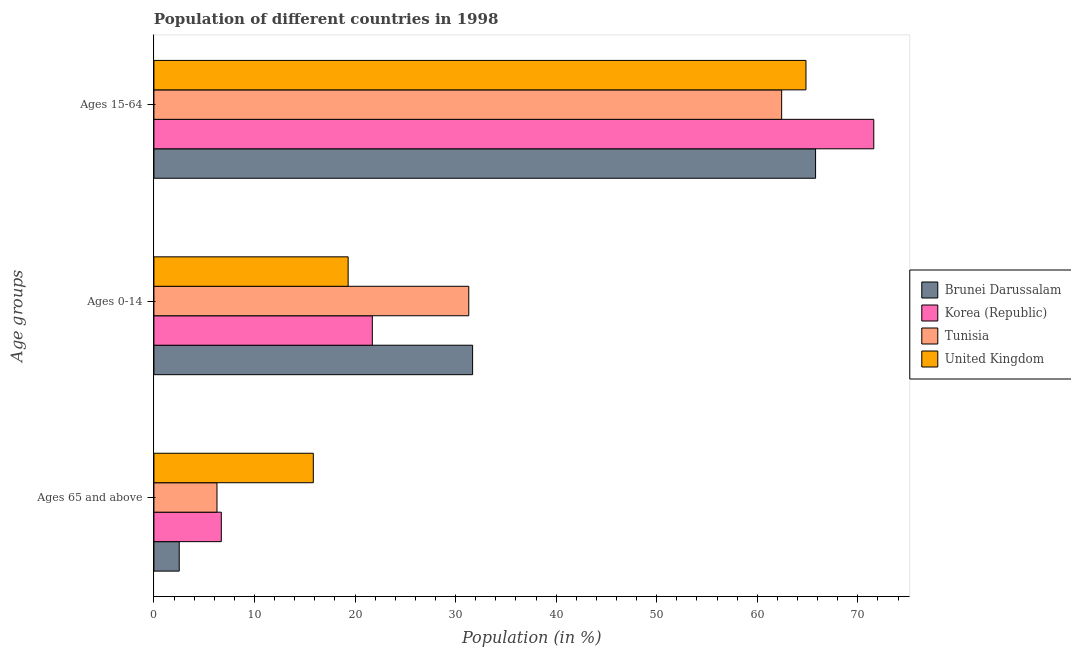Are the number of bars per tick equal to the number of legend labels?
Keep it short and to the point. Yes. Are the number of bars on each tick of the Y-axis equal?
Your response must be concise. Yes. What is the label of the 2nd group of bars from the top?
Give a very brief answer. Ages 0-14. What is the percentage of population within the age-group of 65 and above in United Kingdom?
Provide a short and direct response. 15.85. Across all countries, what is the maximum percentage of population within the age-group 15-64?
Provide a short and direct response. 71.58. Across all countries, what is the minimum percentage of population within the age-group 15-64?
Make the answer very short. 62.42. In which country was the percentage of population within the age-group 15-64 minimum?
Provide a succinct answer. Tunisia. What is the total percentage of population within the age-group of 65 and above in the graph?
Provide a short and direct response. 31.34. What is the difference between the percentage of population within the age-group of 65 and above in Tunisia and that in Korea (Republic)?
Keep it short and to the point. -0.43. What is the difference between the percentage of population within the age-group of 65 and above in Tunisia and the percentage of population within the age-group 15-64 in United Kingdom?
Ensure brevity in your answer.  -58.57. What is the average percentage of population within the age-group 0-14 per country?
Make the answer very short. 26.01. What is the difference between the percentage of population within the age-group of 65 and above and percentage of population within the age-group 15-64 in Brunei Darussalam?
Provide a short and direct response. -63.28. In how many countries, is the percentage of population within the age-group 0-14 greater than 70 %?
Offer a terse response. 0. What is the ratio of the percentage of population within the age-group 0-14 in United Kingdom to that in Brunei Darussalam?
Offer a very short reply. 0.61. Is the percentage of population within the age-group 15-64 in Korea (Republic) less than that in Tunisia?
Keep it short and to the point. No. Is the difference between the percentage of population within the age-group 15-64 in United Kingdom and Brunei Darussalam greater than the difference between the percentage of population within the age-group 0-14 in United Kingdom and Brunei Darussalam?
Your answer should be compact. Yes. What is the difference between the highest and the second highest percentage of population within the age-group of 65 and above?
Ensure brevity in your answer.  9.15. What is the difference between the highest and the lowest percentage of population within the age-group 0-14?
Ensure brevity in your answer.  12.38. In how many countries, is the percentage of population within the age-group of 65 and above greater than the average percentage of population within the age-group of 65 and above taken over all countries?
Provide a short and direct response. 1. What does the 4th bar from the bottom in Ages 15-64 represents?
Offer a terse response. United Kingdom. How many bars are there?
Offer a terse response. 12. How many countries are there in the graph?
Your answer should be very brief. 4. What is the difference between two consecutive major ticks on the X-axis?
Provide a succinct answer. 10. Does the graph contain grids?
Offer a very short reply. No. Where does the legend appear in the graph?
Your answer should be very brief. Center right. How are the legend labels stacked?
Ensure brevity in your answer.  Vertical. What is the title of the graph?
Provide a short and direct response. Population of different countries in 1998. Does "Benin" appear as one of the legend labels in the graph?
Offer a very short reply. No. What is the label or title of the X-axis?
Your answer should be compact. Population (in %). What is the label or title of the Y-axis?
Make the answer very short. Age groups. What is the Population (in %) in Brunei Darussalam in Ages 65 and above?
Give a very brief answer. 2.52. What is the Population (in %) in Korea (Republic) in Ages 65 and above?
Give a very brief answer. 6.7. What is the Population (in %) of Tunisia in Ages 65 and above?
Your response must be concise. 6.27. What is the Population (in %) of United Kingdom in Ages 65 and above?
Make the answer very short. 15.85. What is the Population (in %) of Brunei Darussalam in Ages 0-14?
Keep it short and to the point. 31.69. What is the Population (in %) in Korea (Republic) in Ages 0-14?
Provide a short and direct response. 21.72. What is the Population (in %) of Tunisia in Ages 0-14?
Give a very brief answer. 31.31. What is the Population (in %) of United Kingdom in Ages 0-14?
Provide a short and direct response. 19.31. What is the Population (in %) in Brunei Darussalam in Ages 15-64?
Keep it short and to the point. 65.79. What is the Population (in %) in Korea (Republic) in Ages 15-64?
Provide a succinct answer. 71.58. What is the Population (in %) of Tunisia in Ages 15-64?
Keep it short and to the point. 62.42. What is the Population (in %) in United Kingdom in Ages 15-64?
Provide a short and direct response. 64.84. Across all Age groups, what is the maximum Population (in %) in Brunei Darussalam?
Offer a very short reply. 65.79. Across all Age groups, what is the maximum Population (in %) of Korea (Republic)?
Offer a very short reply. 71.58. Across all Age groups, what is the maximum Population (in %) in Tunisia?
Offer a terse response. 62.42. Across all Age groups, what is the maximum Population (in %) in United Kingdom?
Your answer should be very brief. 64.84. Across all Age groups, what is the minimum Population (in %) of Brunei Darussalam?
Keep it short and to the point. 2.52. Across all Age groups, what is the minimum Population (in %) of Korea (Republic)?
Provide a short and direct response. 6.7. Across all Age groups, what is the minimum Population (in %) of Tunisia?
Keep it short and to the point. 6.27. Across all Age groups, what is the minimum Population (in %) of United Kingdom?
Provide a succinct answer. 15.85. What is the total Population (in %) in Brunei Darussalam in the graph?
Your answer should be very brief. 100. What is the total Population (in %) of Tunisia in the graph?
Provide a short and direct response. 100. What is the total Population (in %) of United Kingdom in the graph?
Make the answer very short. 100. What is the difference between the Population (in %) in Brunei Darussalam in Ages 65 and above and that in Ages 0-14?
Your response must be concise. -29.17. What is the difference between the Population (in %) in Korea (Republic) in Ages 65 and above and that in Ages 0-14?
Give a very brief answer. -15.02. What is the difference between the Population (in %) of Tunisia in Ages 65 and above and that in Ages 0-14?
Keep it short and to the point. -25.04. What is the difference between the Population (in %) of United Kingdom in Ages 65 and above and that in Ages 0-14?
Your answer should be compact. -3.46. What is the difference between the Population (in %) in Brunei Darussalam in Ages 65 and above and that in Ages 15-64?
Ensure brevity in your answer.  -63.28. What is the difference between the Population (in %) in Korea (Republic) in Ages 65 and above and that in Ages 15-64?
Provide a short and direct response. -64.88. What is the difference between the Population (in %) in Tunisia in Ages 65 and above and that in Ages 15-64?
Offer a terse response. -56.15. What is the difference between the Population (in %) of United Kingdom in Ages 65 and above and that in Ages 15-64?
Your answer should be compact. -48.99. What is the difference between the Population (in %) of Brunei Darussalam in Ages 0-14 and that in Ages 15-64?
Your answer should be compact. -34.11. What is the difference between the Population (in %) in Korea (Republic) in Ages 0-14 and that in Ages 15-64?
Offer a very short reply. -49.86. What is the difference between the Population (in %) in Tunisia in Ages 0-14 and that in Ages 15-64?
Offer a very short reply. -31.11. What is the difference between the Population (in %) of United Kingdom in Ages 0-14 and that in Ages 15-64?
Offer a very short reply. -45.53. What is the difference between the Population (in %) of Brunei Darussalam in Ages 65 and above and the Population (in %) of Korea (Republic) in Ages 0-14?
Keep it short and to the point. -19.2. What is the difference between the Population (in %) in Brunei Darussalam in Ages 65 and above and the Population (in %) in Tunisia in Ages 0-14?
Offer a very short reply. -28.79. What is the difference between the Population (in %) in Brunei Darussalam in Ages 65 and above and the Population (in %) in United Kingdom in Ages 0-14?
Give a very brief answer. -16.8. What is the difference between the Population (in %) in Korea (Republic) in Ages 65 and above and the Population (in %) in Tunisia in Ages 0-14?
Ensure brevity in your answer.  -24.61. What is the difference between the Population (in %) in Korea (Republic) in Ages 65 and above and the Population (in %) in United Kingdom in Ages 0-14?
Make the answer very short. -12.61. What is the difference between the Population (in %) in Tunisia in Ages 65 and above and the Population (in %) in United Kingdom in Ages 0-14?
Your answer should be compact. -13.04. What is the difference between the Population (in %) of Brunei Darussalam in Ages 65 and above and the Population (in %) of Korea (Republic) in Ages 15-64?
Your answer should be compact. -69.06. What is the difference between the Population (in %) of Brunei Darussalam in Ages 65 and above and the Population (in %) of Tunisia in Ages 15-64?
Give a very brief answer. -59.9. What is the difference between the Population (in %) in Brunei Darussalam in Ages 65 and above and the Population (in %) in United Kingdom in Ages 15-64?
Your answer should be compact. -62.32. What is the difference between the Population (in %) of Korea (Republic) in Ages 65 and above and the Population (in %) of Tunisia in Ages 15-64?
Ensure brevity in your answer.  -55.72. What is the difference between the Population (in %) of Korea (Republic) in Ages 65 and above and the Population (in %) of United Kingdom in Ages 15-64?
Provide a succinct answer. -58.14. What is the difference between the Population (in %) in Tunisia in Ages 65 and above and the Population (in %) in United Kingdom in Ages 15-64?
Give a very brief answer. -58.57. What is the difference between the Population (in %) of Brunei Darussalam in Ages 0-14 and the Population (in %) of Korea (Republic) in Ages 15-64?
Make the answer very short. -39.89. What is the difference between the Population (in %) of Brunei Darussalam in Ages 0-14 and the Population (in %) of Tunisia in Ages 15-64?
Provide a succinct answer. -30.73. What is the difference between the Population (in %) of Brunei Darussalam in Ages 0-14 and the Population (in %) of United Kingdom in Ages 15-64?
Your answer should be very brief. -33.15. What is the difference between the Population (in %) of Korea (Republic) in Ages 0-14 and the Population (in %) of Tunisia in Ages 15-64?
Keep it short and to the point. -40.7. What is the difference between the Population (in %) in Korea (Republic) in Ages 0-14 and the Population (in %) in United Kingdom in Ages 15-64?
Your answer should be very brief. -43.12. What is the difference between the Population (in %) of Tunisia in Ages 0-14 and the Population (in %) of United Kingdom in Ages 15-64?
Your answer should be very brief. -33.53. What is the average Population (in %) of Brunei Darussalam per Age groups?
Provide a succinct answer. 33.33. What is the average Population (in %) in Korea (Republic) per Age groups?
Ensure brevity in your answer.  33.33. What is the average Population (in %) of Tunisia per Age groups?
Offer a terse response. 33.33. What is the average Population (in %) in United Kingdom per Age groups?
Provide a short and direct response. 33.33. What is the difference between the Population (in %) in Brunei Darussalam and Population (in %) in Korea (Republic) in Ages 65 and above?
Offer a terse response. -4.18. What is the difference between the Population (in %) in Brunei Darussalam and Population (in %) in Tunisia in Ages 65 and above?
Your response must be concise. -3.75. What is the difference between the Population (in %) in Brunei Darussalam and Population (in %) in United Kingdom in Ages 65 and above?
Offer a very short reply. -13.33. What is the difference between the Population (in %) in Korea (Republic) and Population (in %) in Tunisia in Ages 65 and above?
Give a very brief answer. 0.43. What is the difference between the Population (in %) in Korea (Republic) and Population (in %) in United Kingdom in Ages 65 and above?
Your answer should be compact. -9.15. What is the difference between the Population (in %) of Tunisia and Population (in %) of United Kingdom in Ages 65 and above?
Your answer should be compact. -9.58. What is the difference between the Population (in %) in Brunei Darussalam and Population (in %) in Korea (Republic) in Ages 0-14?
Make the answer very short. 9.97. What is the difference between the Population (in %) in Brunei Darussalam and Population (in %) in Tunisia in Ages 0-14?
Offer a terse response. 0.38. What is the difference between the Population (in %) of Brunei Darussalam and Population (in %) of United Kingdom in Ages 0-14?
Make the answer very short. 12.38. What is the difference between the Population (in %) of Korea (Republic) and Population (in %) of Tunisia in Ages 0-14?
Ensure brevity in your answer.  -9.59. What is the difference between the Population (in %) of Korea (Republic) and Population (in %) of United Kingdom in Ages 0-14?
Your response must be concise. 2.4. What is the difference between the Population (in %) of Tunisia and Population (in %) of United Kingdom in Ages 0-14?
Ensure brevity in your answer.  12. What is the difference between the Population (in %) in Brunei Darussalam and Population (in %) in Korea (Republic) in Ages 15-64?
Your answer should be compact. -5.79. What is the difference between the Population (in %) in Brunei Darussalam and Population (in %) in Tunisia in Ages 15-64?
Your answer should be very brief. 3.37. What is the difference between the Population (in %) in Brunei Darussalam and Population (in %) in United Kingdom in Ages 15-64?
Offer a very short reply. 0.96. What is the difference between the Population (in %) of Korea (Republic) and Population (in %) of Tunisia in Ages 15-64?
Offer a terse response. 9.16. What is the difference between the Population (in %) of Korea (Republic) and Population (in %) of United Kingdom in Ages 15-64?
Offer a very short reply. 6.74. What is the difference between the Population (in %) in Tunisia and Population (in %) in United Kingdom in Ages 15-64?
Make the answer very short. -2.42. What is the ratio of the Population (in %) of Brunei Darussalam in Ages 65 and above to that in Ages 0-14?
Provide a succinct answer. 0.08. What is the ratio of the Population (in %) in Korea (Republic) in Ages 65 and above to that in Ages 0-14?
Give a very brief answer. 0.31. What is the ratio of the Population (in %) in Tunisia in Ages 65 and above to that in Ages 0-14?
Offer a very short reply. 0.2. What is the ratio of the Population (in %) of United Kingdom in Ages 65 and above to that in Ages 0-14?
Your answer should be compact. 0.82. What is the ratio of the Population (in %) in Brunei Darussalam in Ages 65 and above to that in Ages 15-64?
Offer a very short reply. 0.04. What is the ratio of the Population (in %) in Korea (Republic) in Ages 65 and above to that in Ages 15-64?
Offer a very short reply. 0.09. What is the ratio of the Population (in %) of Tunisia in Ages 65 and above to that in Ages 15-64?
Offer a terse response. 0.1. What is the ratio of the Population (in %) in United Kingdom in Ages 65 and above to that in Ages 15-64?
Offer a terse response. 0.24. What is the ratio of the Population (in %) in Brunei Darussalam in Ages 0-14 to that in Ages 15-64?
Give a very brief answer. 0.48. What is the ratio of the Population (in %) of Korea (Republic) in Ages 0-14 to that in Ages 15-64?
Give a very brief answer. 0.3. What is the ratio of the Population (in %) in Tunisia in Ages 0-14 to that in Ages 15-64?
Your response must be concise. 0.5. What is the ratio of the Population (in %) of United Kingdom in Ages 0-14 to that in Ages 15-64?
Offer a terse response. 0.3. What is the difference between the highest and the second highest Population (in %) in Brunei Darussalam?
Your answer should be compact. 34.11. What is the difference between the highest and the second highest Population (in %) in Korea (Republic)?
Offer a very short reply. 49.86. What is the difference between the highest and the second highest Population (in %) of Tunisia?
Give a very brief answer. 31.11. What is the difference between the highest and the second highest Population (in %) of United Kingdom?
Make the answer very short. 45.53. What is the difference between the highest and the lowest Population (in %) of Brunei Darussalam?
Your response must be concise. 63.28. What is the difference between the highest and the lowest Population (in %) of Korea (Republic)?
Provide a short and direct response. 64.88. What is the difference between the highest and the lowest Population (in %) in Tunisia?
Provide a short and direct response. 56.15. What is the difference between the highest and the lowest Population (in %) of United Kingdom?
Your answer should be compact. 48.99. 